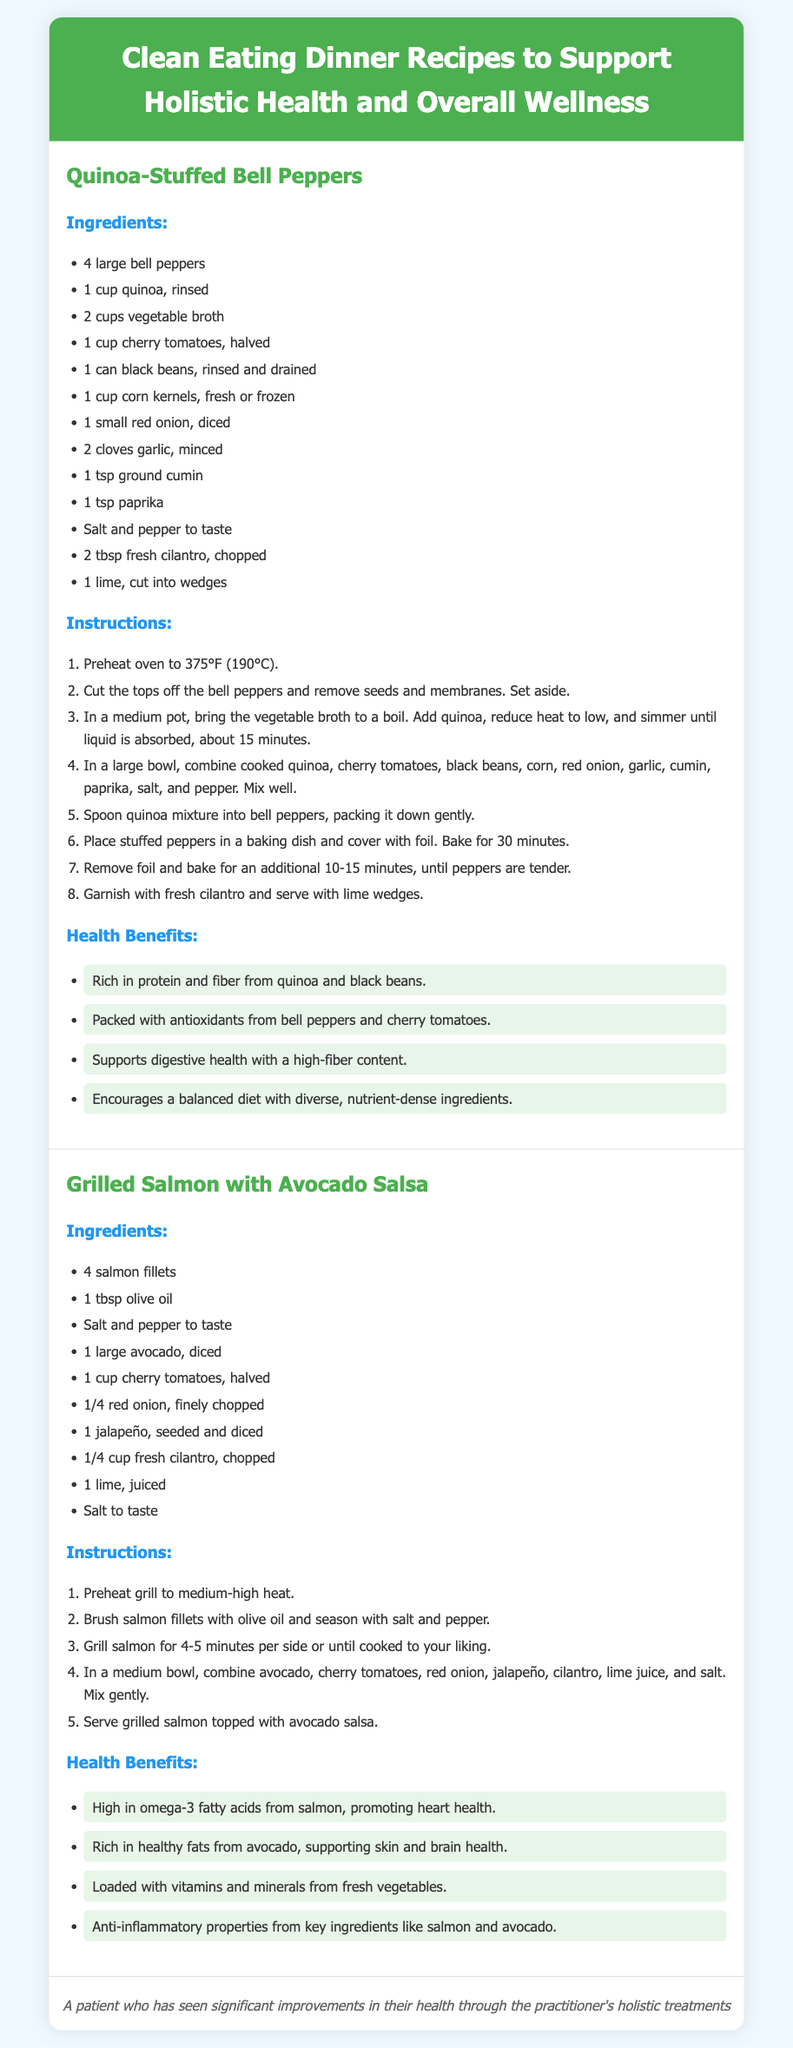What are the main ingredients for Quinoa-Stuffed Bell Peppers? The ingredients listed in the recipe specifically for Quinoa-Stuffed Bell Peppers include 4 large bell peppers, 1 cup quinoa, 2 cups vegetable broth, and other components.
Answer: 4 large bell peppers, 1 cup quinoa, 2 cups vegetable broth, 1 cup cherry tomatoes, 1 can black beans, 1 cup corn kernels, 1 small red onion, 2 cloves garlic, 1 tsp ground cumin, 1 tsp paprika, salt and pepper, 2 tbsp fresh cilantro, 1 lime What is the cooking temperature for the Quinoa-Stuffed Bell Peppers? The recipe specifies that the oven should be preheated to 375°F (190°C) for cooking the Quinoa-Stuffed Bell Peppers.
Answer: 375°F (190°C) How long should the salmon be grilled? The grilling instructions indicate that the salmon should be grilled for 4-5 minutes per side.
Answer: 4-5 minutes per side What health benefit is associated with the omega-3 fatty acids in the Grilled Salmon? The document highlights that omega-3 fatty acids from salmon promote heart health.
Answer: Promoting heart health How many salmon fillets are needed for the Grilled Salmon recipe? The ingredients section states that 4 salmon fillets are required for the recipe.
Answer: 4 salmon fillets What fresh ingredient is used in the avocado salsa? The ingredients for the avocado salsa include several fresh ingredients like avocado, cherry tomatoes, red onion, jalapeño, and cilantro.
Answer: Avocado, cherry tomatoes, red onion, jalapeño, cilantro Which ingredient contributes anti-inflammatory properties in the Grilled Salmon recipe? The document mentions that salmon and avocado are key ingredients contributing anti-inflammatory properties.
Answer: Salmon and avocado What is the total baking time for the Quinoa-Stuffed Bell Peppers? The instructions specify that the peppers are to be baked for a total of 40-45 minutes (30 minutes covered and an additional 10-15 minutes uncovered).
Answer: 40-45 minutes 